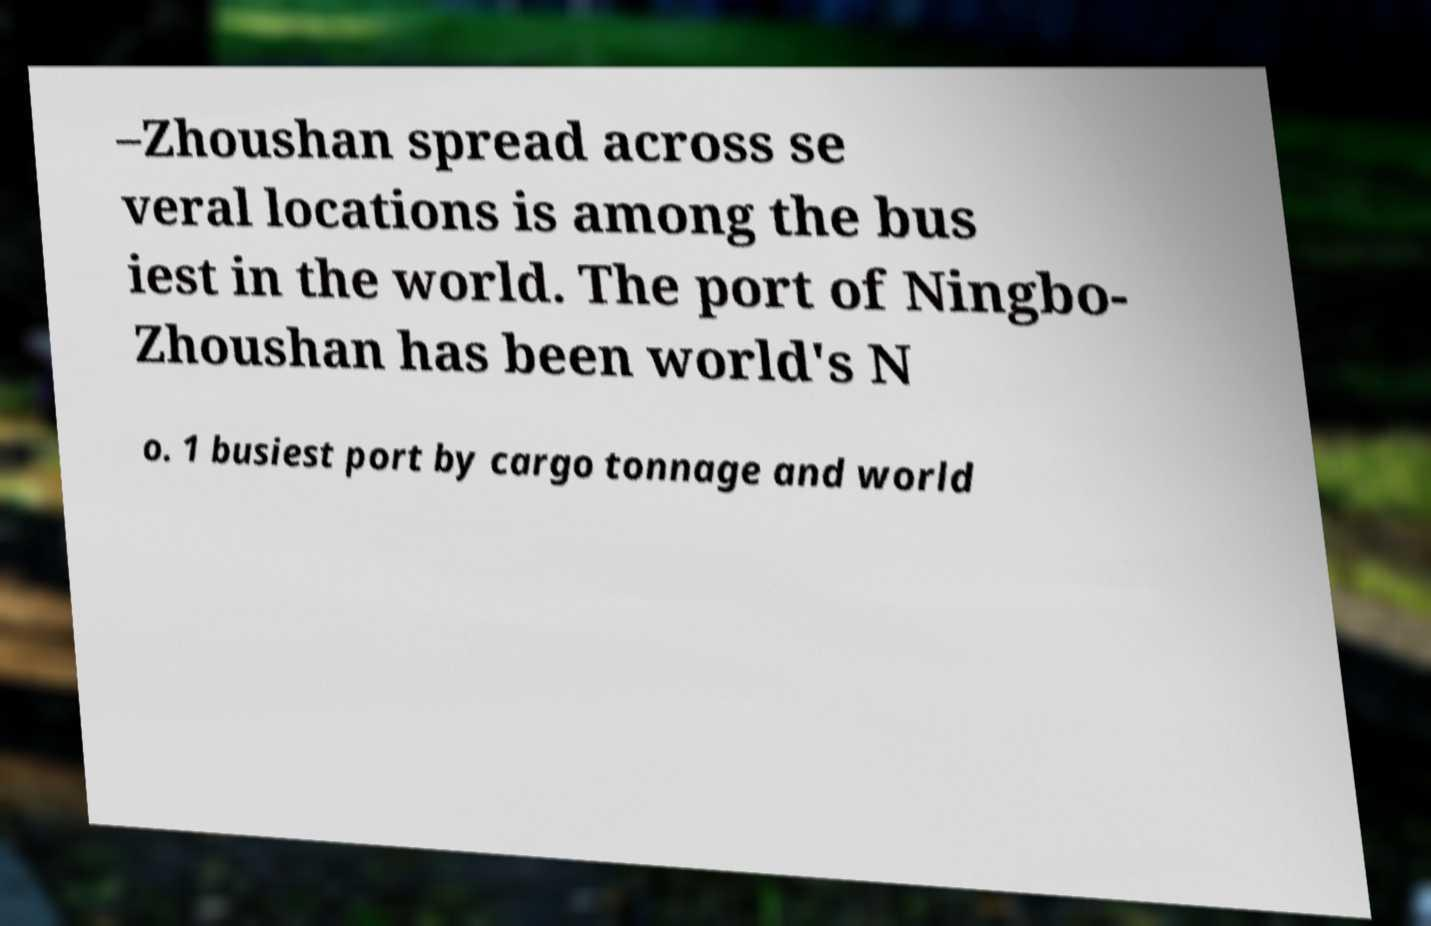Could you assist in decoding the text presented in this image and type it out clearly? –Zhoushan spread across se veral locations is among the bus iest in the world. The port of Ningbo- Zhoushan has been world's N o. 1 busiest port by cargo tonnage and world 